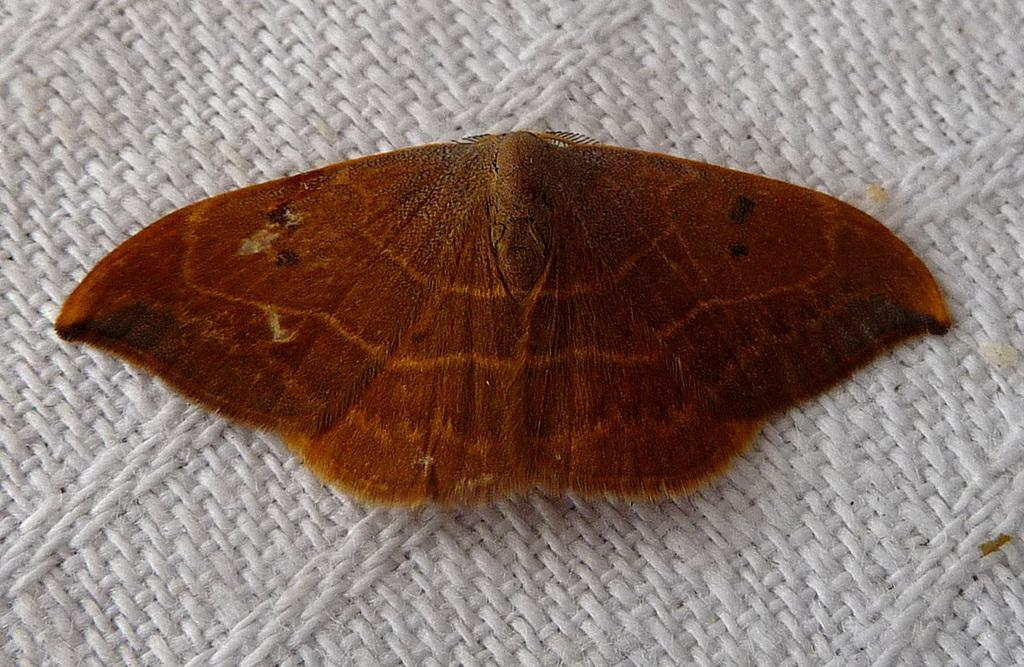What type of animal can be seen in the image? There is a butterfly in the image. What is located at the bottom of the image? There is a cloth at the bottom of the image. What historical events are mentioned in the songs sung by the butterfly in the image? There are no songs or historical events mentioned in the image, as it features a butterfly and a cloth. 